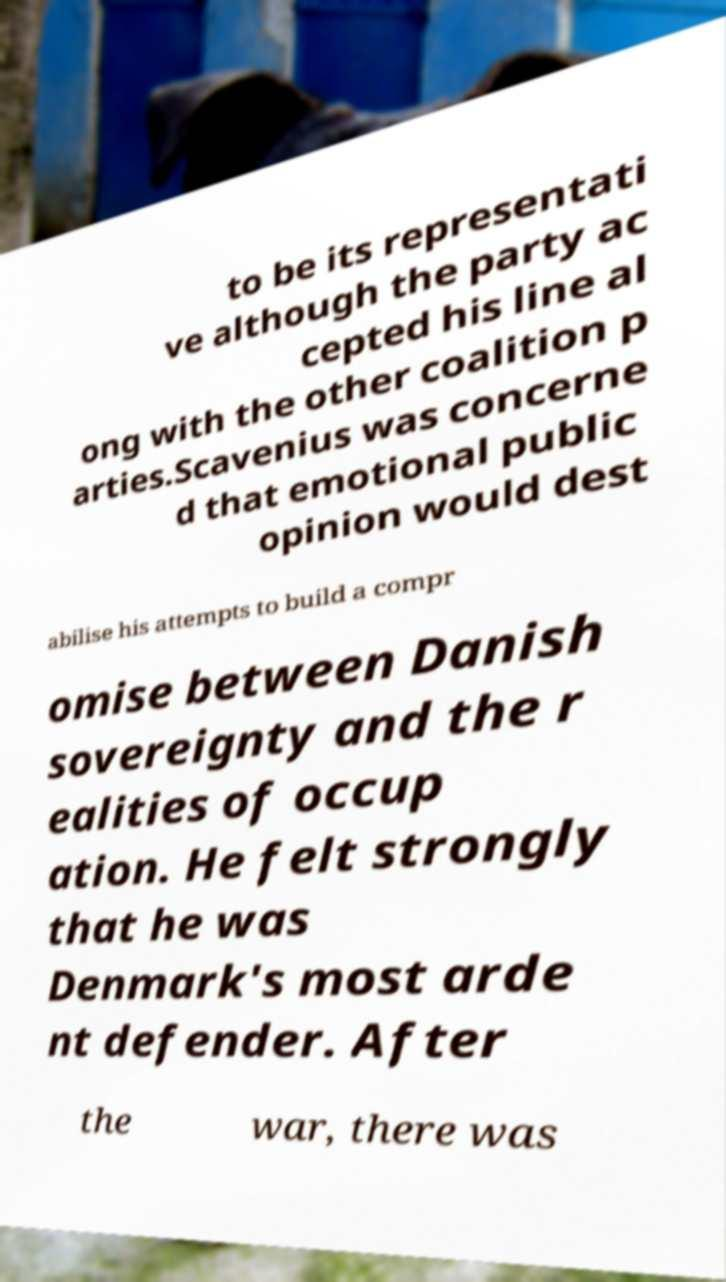I need the written content from this picture converted into text. Can you do that? to be its representati ve although the party ac cepted his line al ong with the other coalition p arties.Scavenius was concerne d that emotional public opinion would dest abilise his attempts to build a compr omise between Danish sovereignty and the r ealities of occup ation. He felt strongly that he was Denmark's most arde nt defender. After the war, there was 